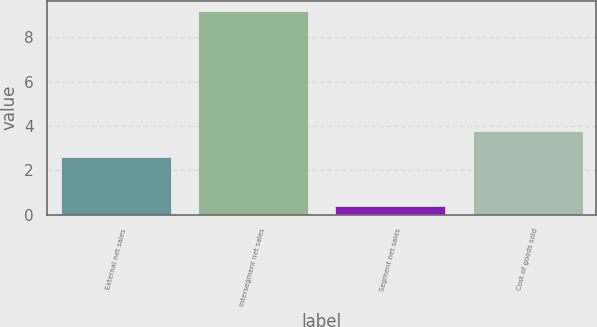<chart> <loc_0><loc_0><loc_500><loc_500><bar_chart><fcel>External net sales<fcel>Intersegment net sales<fcel>Segment net sales<fcel>Cost of goods sold<nl><fcel>2.6<fcel>9.2<fcel>0.4<fcel>3.8<nl></chart> 